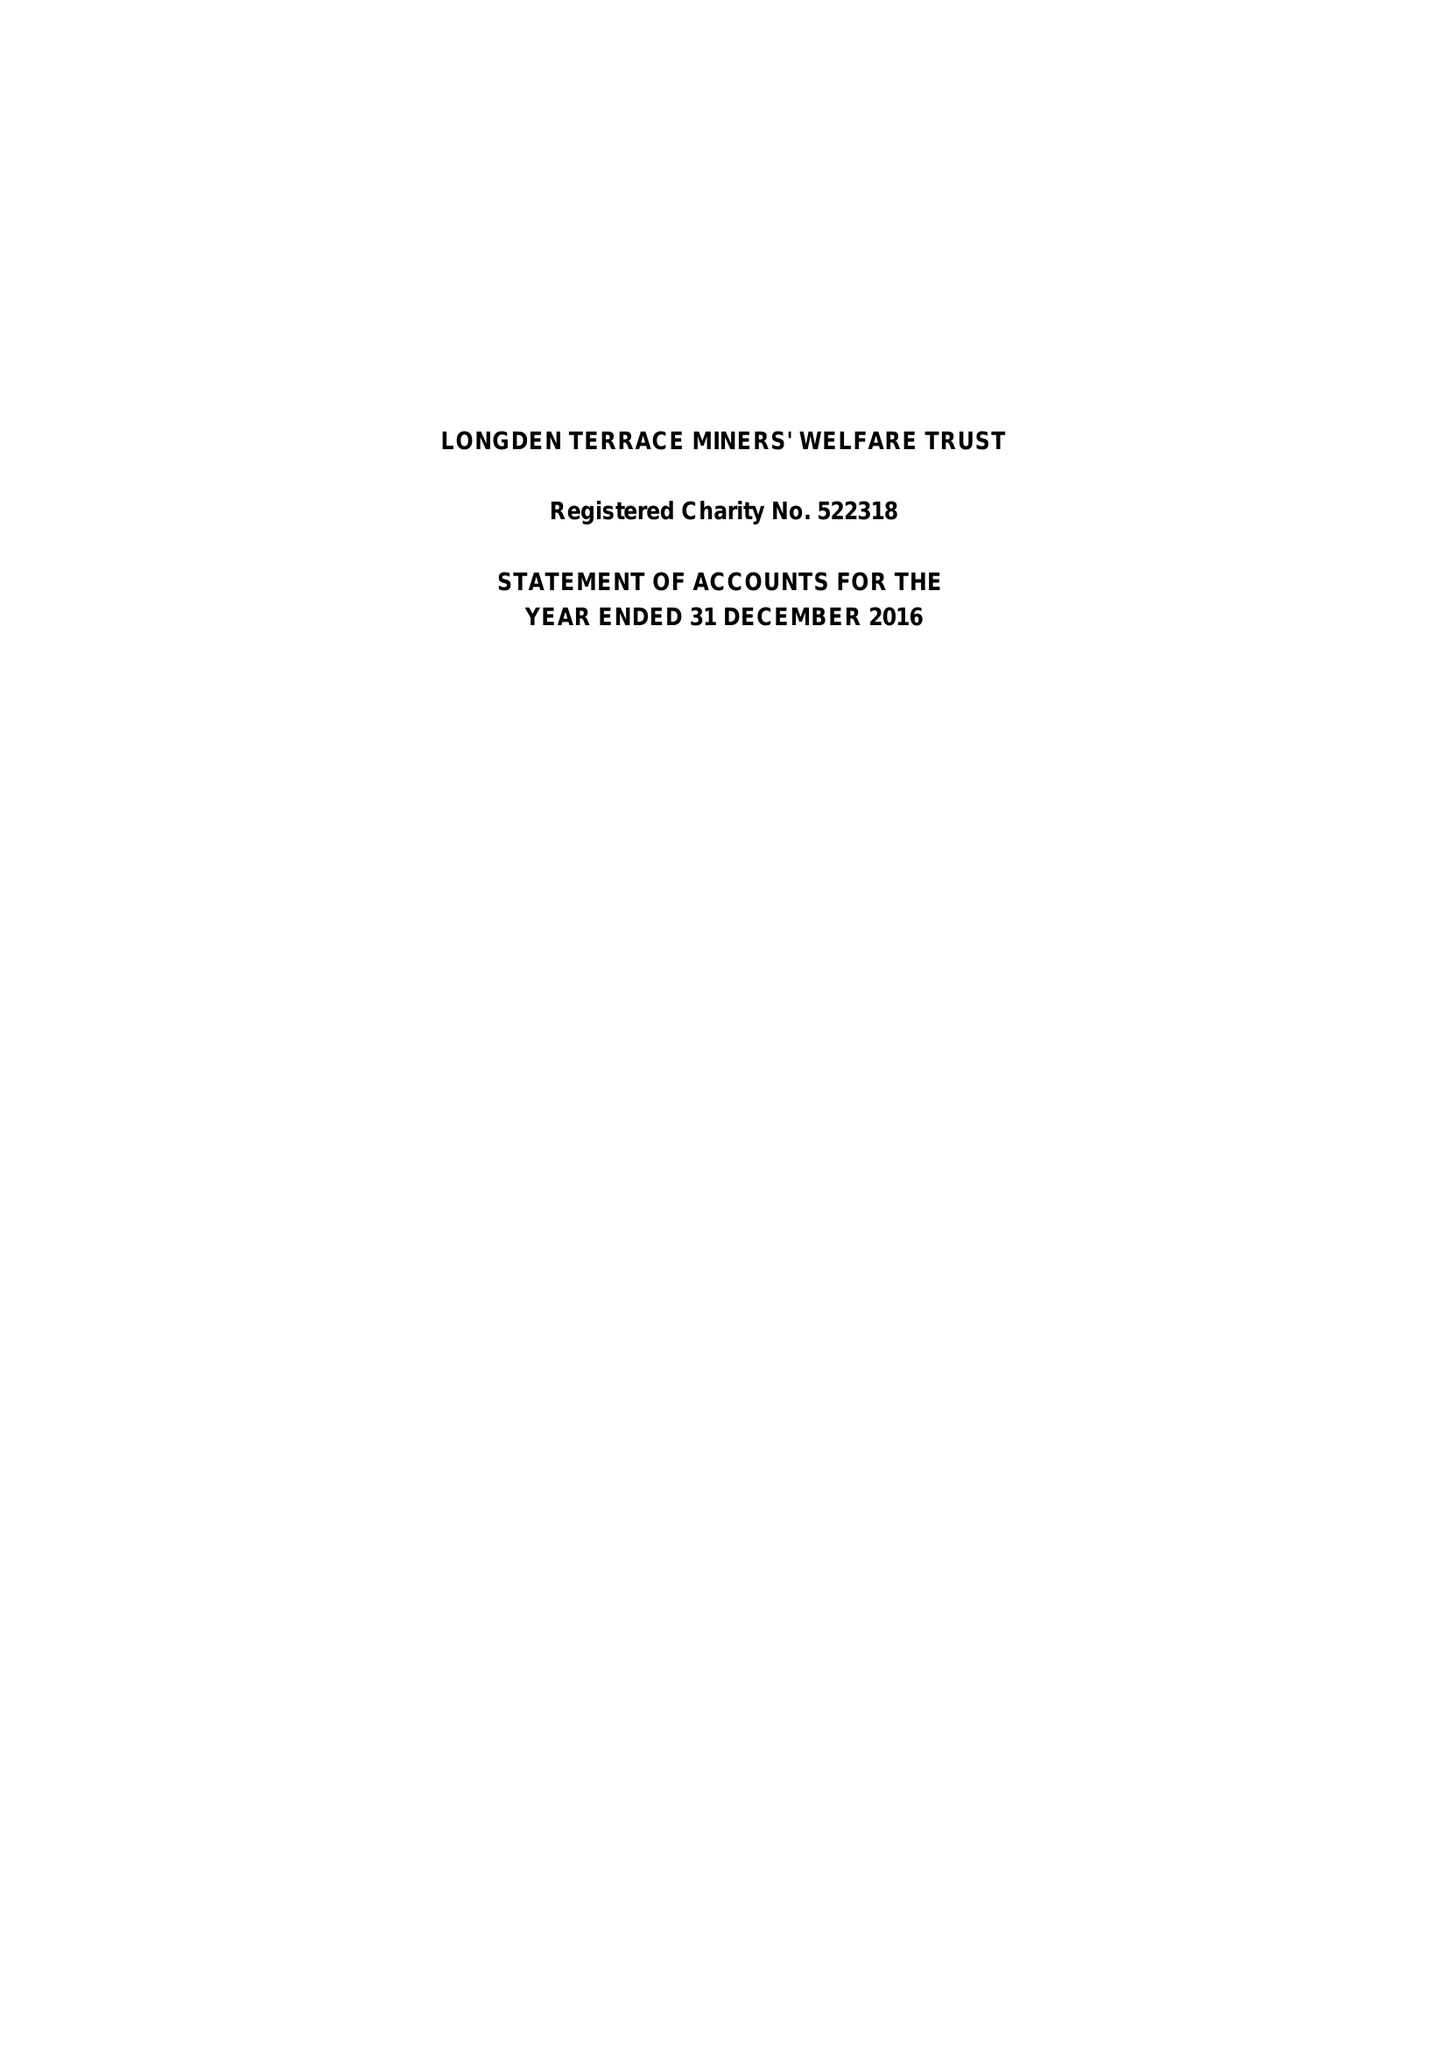What is the value for the address__postcode?
Answer the question using a single word or phrase. NG21 9JW 